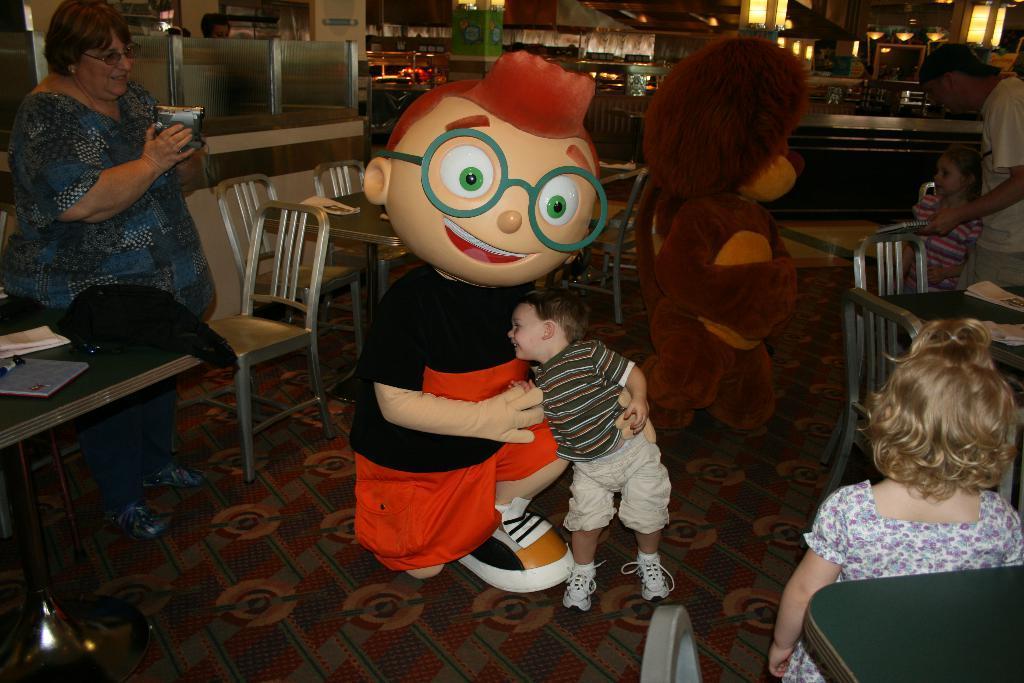Could you give a brief overview of what you see in this image? In this picture there is a man wearing cartoon costume holding a small boy beside him. On the left side there is a old women wearing blue color shirt sitting and smiling. In the background there is a view of the restaurant with some dining tables and chairs. 